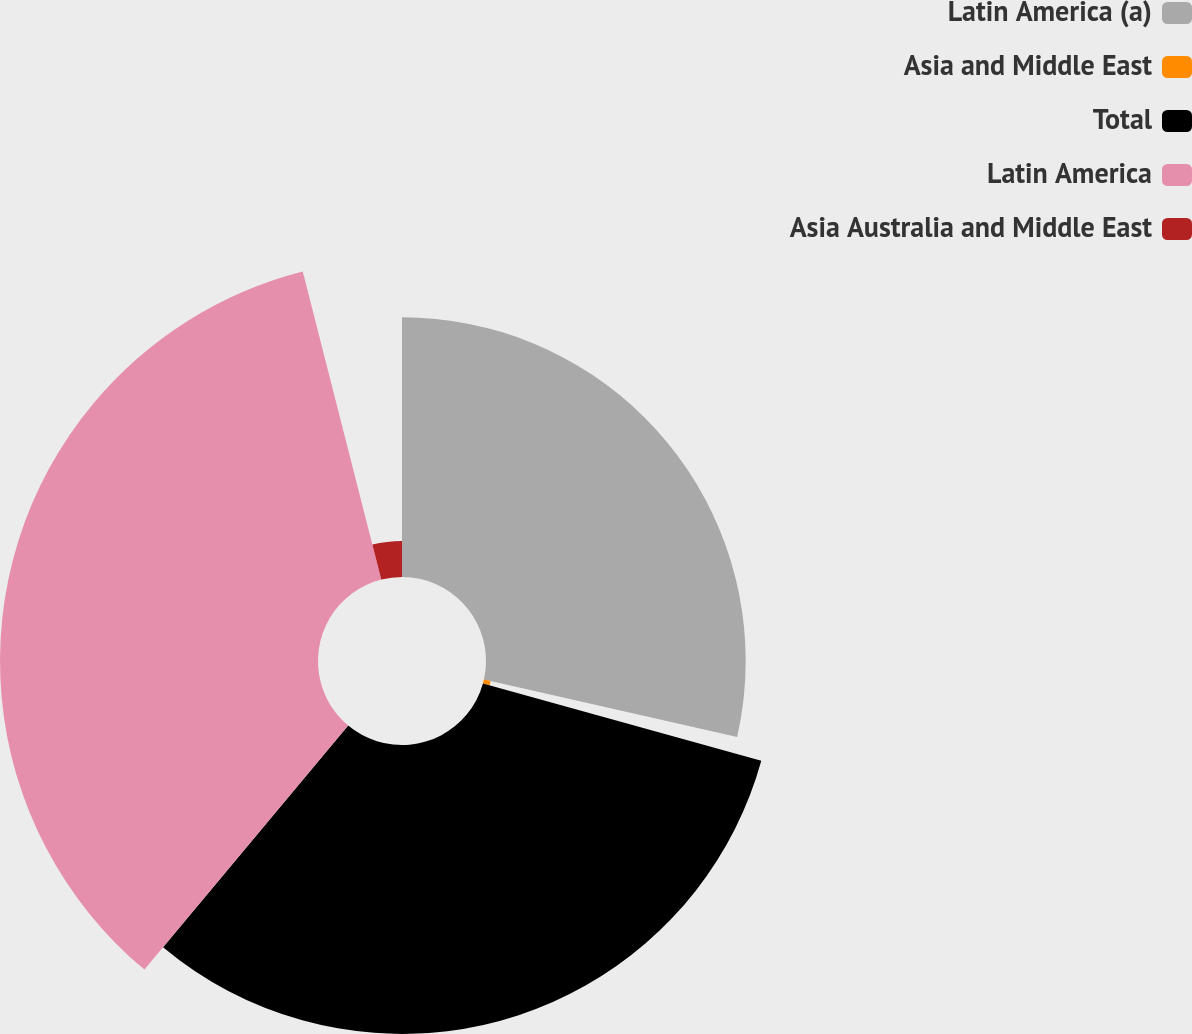Convert chart. <chart><loc_0><loc_0><loc_500><loc_500><pie_chart><fcel>Latin America (a)<fcel>Asia and Middle East<fcel>Total<fcel>Latin America<fcel>Asia Australia and Middle East<nl><fcel>28.55%<fcel>0.76%<fcel>31.76%<fcel>34.96%<fcel>3.97%<nl></chart> 